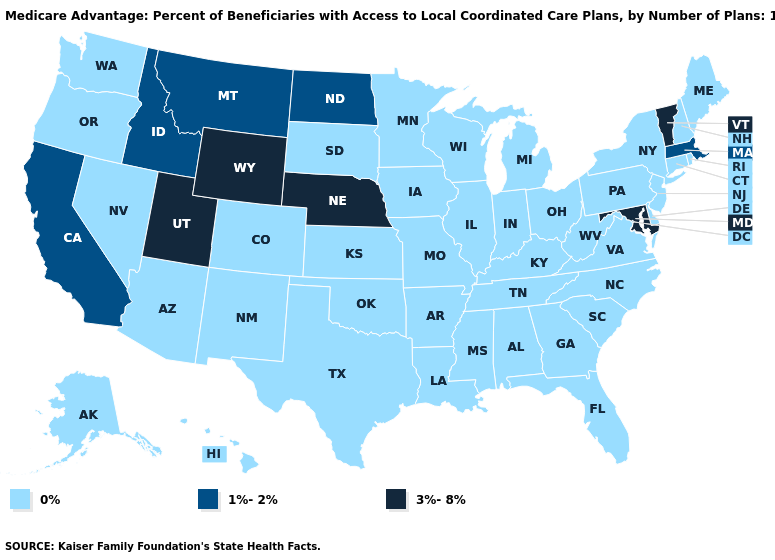Name the states that have a value in the range 3%-8%?
Short answer required. Maryland, Nebraska, Utah, Vermont, Wyoming. Name the states that have a value in the range 0%?
Concise answer only. Colorado, Connecticut, Delaware, Florida, Georgia, Hawaii, Iowa, Illinois, Indiana, Kansas, Kentucky, Louisiana, Maine, Michigan, Minnesota, Missouri, Mississippi, North Carolina, New Hampshire, New Jersey, New Mexico, Nevada, New York, Ohio, Oklahoma, Oregon, Pennsylvania, Rhode Island, South Carolina, South Dakota, Alaska, Tennessee, Texas, Virginia, Washington, Wisconsin, West Virginia, Alabama, Arkansas, Arizona. Does the first symbol in the legend represent the smallest category?
Short answer required. Yes. What is the lowest value in the USA?
Answer briefly. 0%. Name the states that have a value in the range 0%?
Give a very brief answer. Colorado, Connecticut, Delaware, Florida, Georgia, Hawaii, Iowa, Illinois, Indiana, Kansas, Kentucky, Louisiana, Maine, Michigan, Minnesota, Missouri, Mississippi, North Carolina, New Hampshire, New Jersey, New Mexico, Nevada, New York, Ohio, Oklahoma, Oregon, Pennsylvania, Rhode Island, South Carolina, South Dakota, Alaska, Tennessee, Texas, Virginia, Washington, Wisconsin, West Virginia, Alabama, Arkansas, Arizona. Does the first symbol in the legend represent the smallest category?
Quick response, please. Yes. Which states have the lowest value in the USA?
Keep it brief. Colorado, Connecticut, Delaware, Florida, Georgia, Hawaii, Iowa, Illinois, Indiana, Kansas, Kentucky, Louisiana, Maine, Michigan, Minnesota, Missouri, Mississippi, North Carolina, New Hampshire, New Jersey, New Mexico, Nevada, New York, Ohio, Oklahoma, Oregon, Pennsylvania, Rhode Island, South Carolina, South Dakota, Alaska, Tennessee, Texas, Virginia, Washington, Wisconsin, West Virginia, Alabama, Arkansas, Arizona. What is the value of Florida?
Concise answer only. 0%. Name the states that have a value in the range 1%-2%?
Give a very brief answer. California, Idaho, Massachusetts, Montana, North Dakota. Is the legend a continuous bar?
Answer briefly. No. Name the states that have a value in the range 3%-8%?
Concise answer only. Maryland, Nebraska, Utah, Vermont, Wyoming. Name the states that have a value in the range 3%-8%?
Write a very short answer. Maryland, Nebraska, Utah, Vermont, Wyoming. What is the value of North Dakota?
Concise answer only. 1%-2%. Among the states that border Ohio , which have the highest value?
Quick response, please. Indiana, Kentucky, Michigan, Pennsylvania, West Virginia. What is the value of Wyoming?
Answer briefly. 3%-8%. 